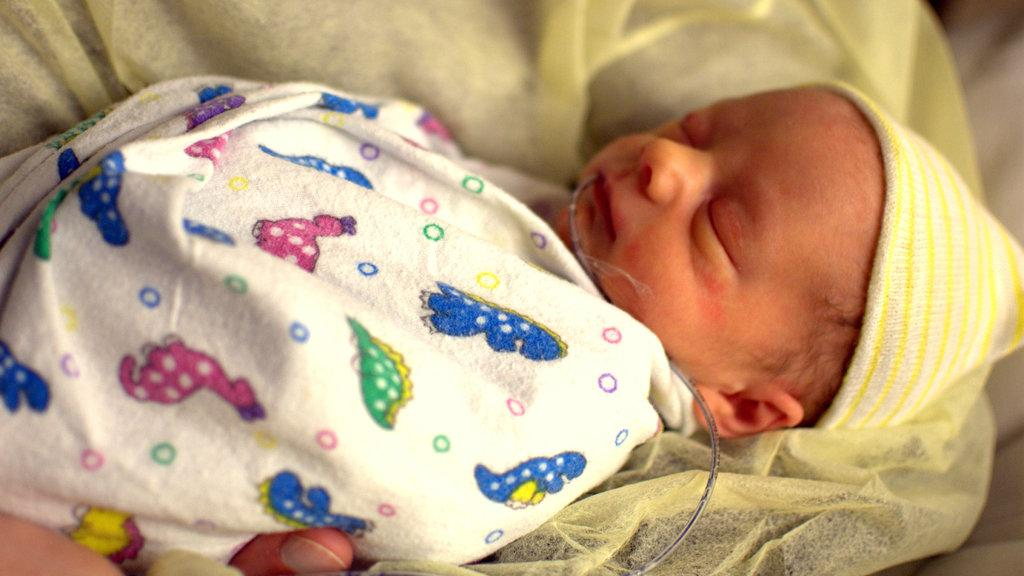What is the main subject in the foreground of the image? There is a baby in the foreground of the image. Can you describe the person in the image? There is a person in the image, and they are carrying a pipe. What is the relationship between the person and the baby in the image? The pipe is in the baby's mouth, suggesting that the person is likely the baby's caregiver. What type of verse can be heard being recited by the ghost in the image? There is no ghost present in the image, and therefore no verse can be heard being recited. 